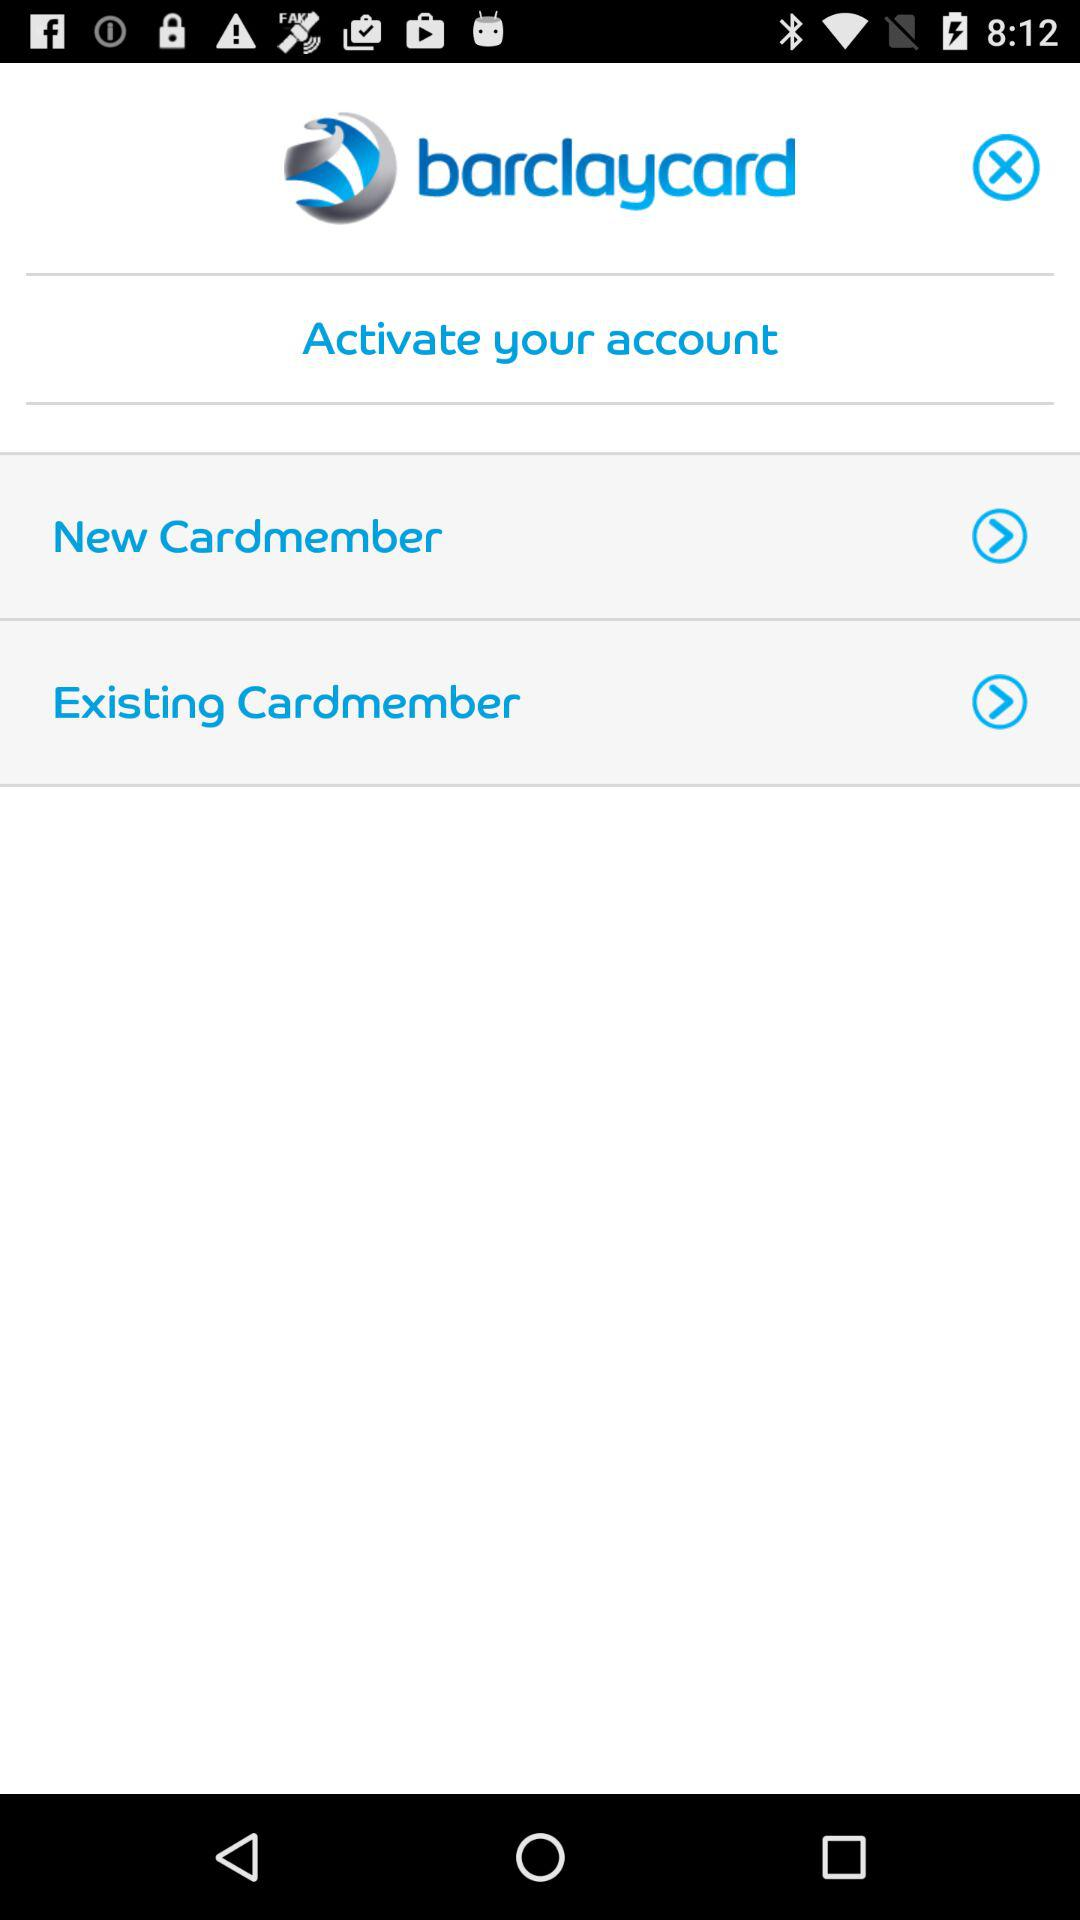What is the application name? The application name is "barclaycard". 